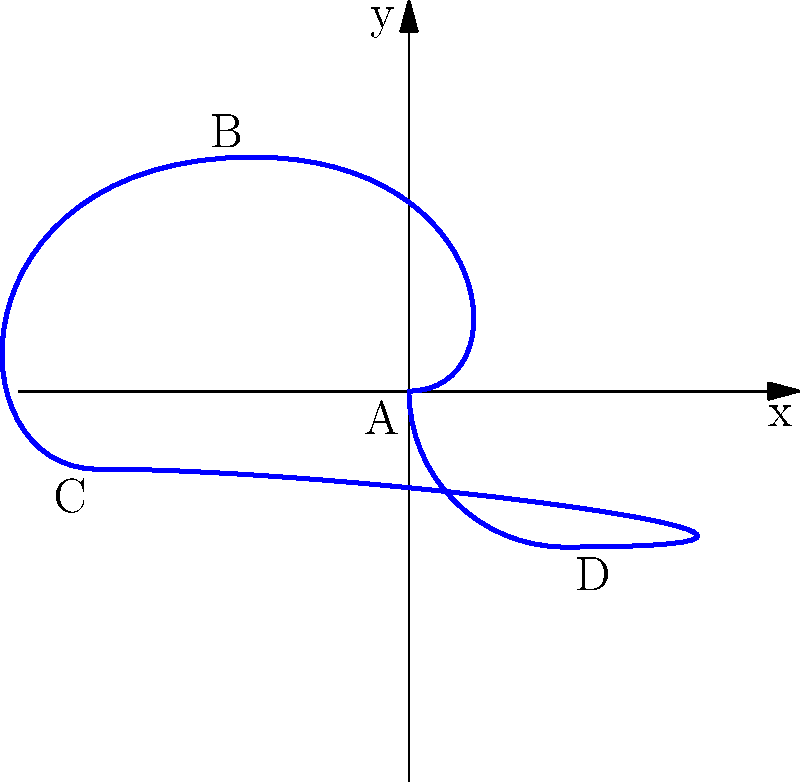As a hip-hop artist exploring complex scratch techniques, you're analyzing the path of a vinyl record during a particular scratch. The movement is represented in a coordinate system where each unit corresponds to 1 inch of record movement. The scratch starts at point A (0,0), moves through points B (-2,3) and C (-4,-1), then to D (2,-2), before returning to A. What is the total distance traveled by the stylus during this scratch, rounded to the nearest inch? To find the total distance traveled, we need to calculate the length of each segment of the path and sum them up. We'll use the distance formula between two points: $d = \sqrt{(x_2-x_1)^2 + (y_2-y_1)^2}$

1. Distance from A(0,0) to B(-2,3):
   $d_{AB} = \sqrt{(-2-0)^2 + (3-0)^2} = \sqrt{4 + 9} = \sqrt{13}$ inches

2. Distance from B(-2,3) to C(-4,-1):
   $d_{BC} = \sqrt{(-4-(-2))^2 + (-1-3)^2} = \sqrt{4 + 16} = \sqrt{20}$ inches

3. Distance from C(-4,-1) to D(2,-2):
   $d_{CD} = \sqrt{(2-(-4))^2 + (-2-(-1))^2} = \sqrt{36 + 1} = \sqrt{37}$ inches

4. Distance from D(2,-2) to A(0,0):
   $d_{DA} = \sqrt{(0-2)^2 + (0-(-2))^2} = \sqrt{4 + 4} = \sqrt{8}$ inches

5. Total distance:
   $d_{total} = \sqrt{13} + \sqrt{20} + \sqrt{37} + \sqrt{8}$ inches

6. Calculate and round to the nearest inch:
   $d_{total} \approx 3.61 + 4.47 + 6.08 + 2.83 = 16.99$ inches

Rounded to the nearest inch, the total distance is 17 inches.
Answer: 17 inches 